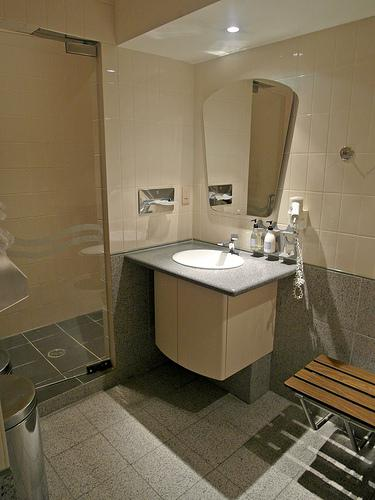Question: where is the mirror?
Choices:
A. On the door.
B. On the wall.
C. Above the sink.
D. On the ceiling.
Answer with the letter. Answer: C Question: where is the soap dispenser?
Choices:
A. Right of sink.
B. Left of sink.
C. Over sink.
D. Under sink.
Answer with the letter. Answer: A Question: how many people are visible?
Choices:
A. Zero.
B. Two.
C. Three.
D. Four.
Answer with the letter. Answer: A Question: what is the visible door made of?
Choices:
A. Wood.
B. Vinyl.
C. Beads.
D. Glass.
Answer with the letter. Answer: D Question: where is the pictured light?
Choices:
A. At church.
B. Above the vanity.
C. The nursing home.
D. The museum.
Answer with the letter. Answer: B 